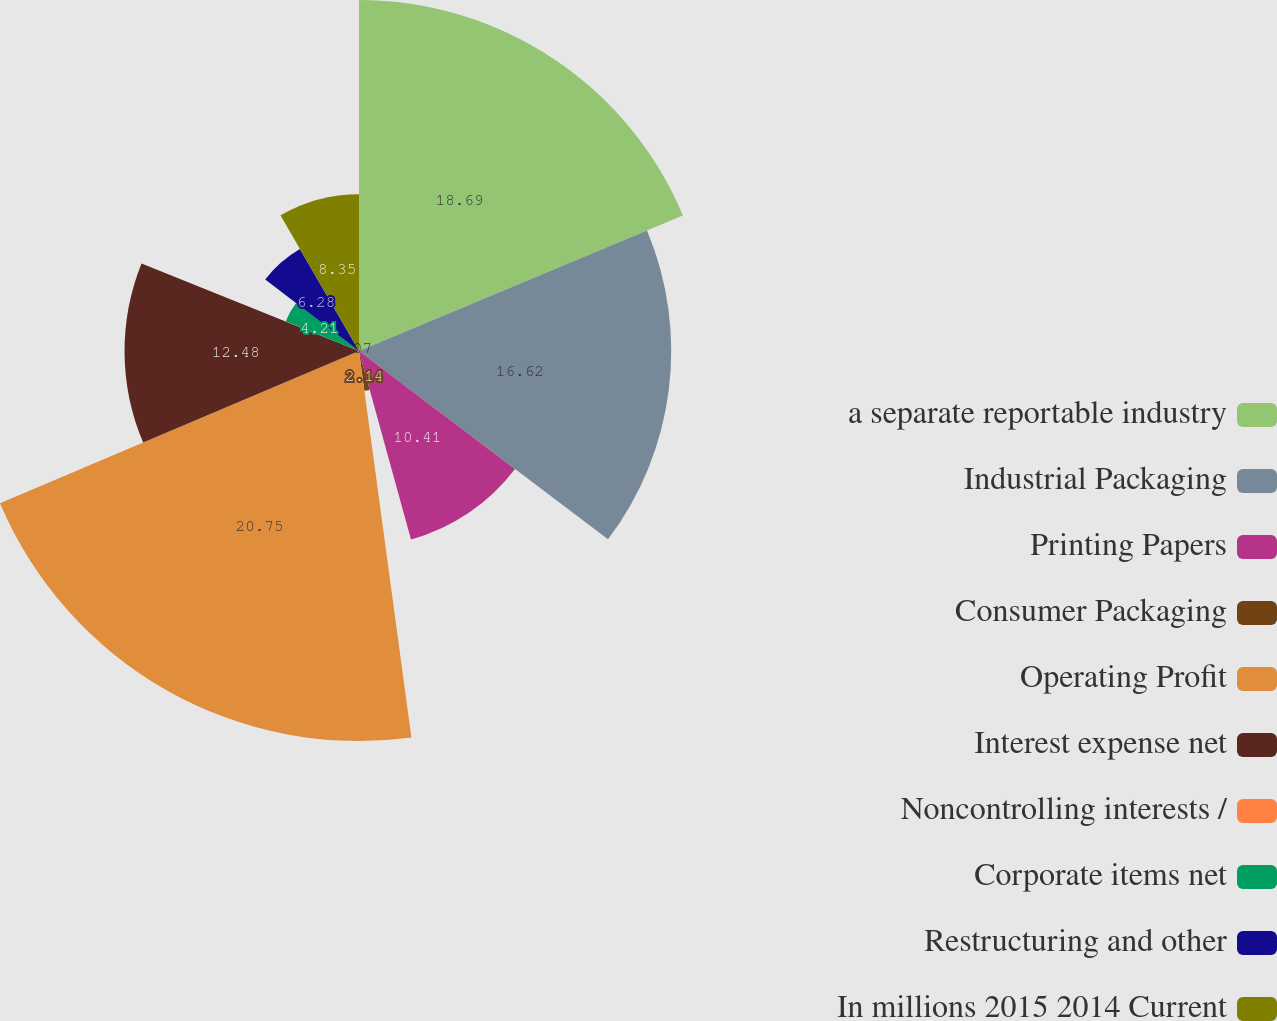Convert chart. <chart><loc_0><loc_0><loc_500><loc_500><pie_chart><fcel>a separate reportable industry<fcel>Industrial Packaging<fcel>Printing Papers<fcel>Consumer Packaging<fcel>Operating Profit<fcel>Interest expense net<fcel>Noncontrolling interests /<fcel>Corporate items net<fcel>Restructuring and other<fcel>In millions 2015 2014 Current<nl><fcel>18.69%<fcel>16.62%<fcel>10.41%<fcel>2.14%<fcel>20.76%<fcel>12.48%<fcel>0.07%<fcel>4.21%<fcel>6.28%<fcel>8.35%<nl></chart> 